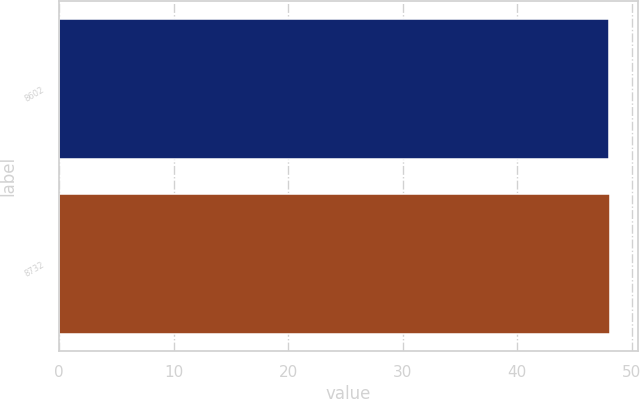Convert chart. <chart><loc_0><loc_0><loc_500><loc_500><bar_chart><fcel>8602<fcel>8732<nl><fcel>48.04<fcel>48.14<nl></chart> 